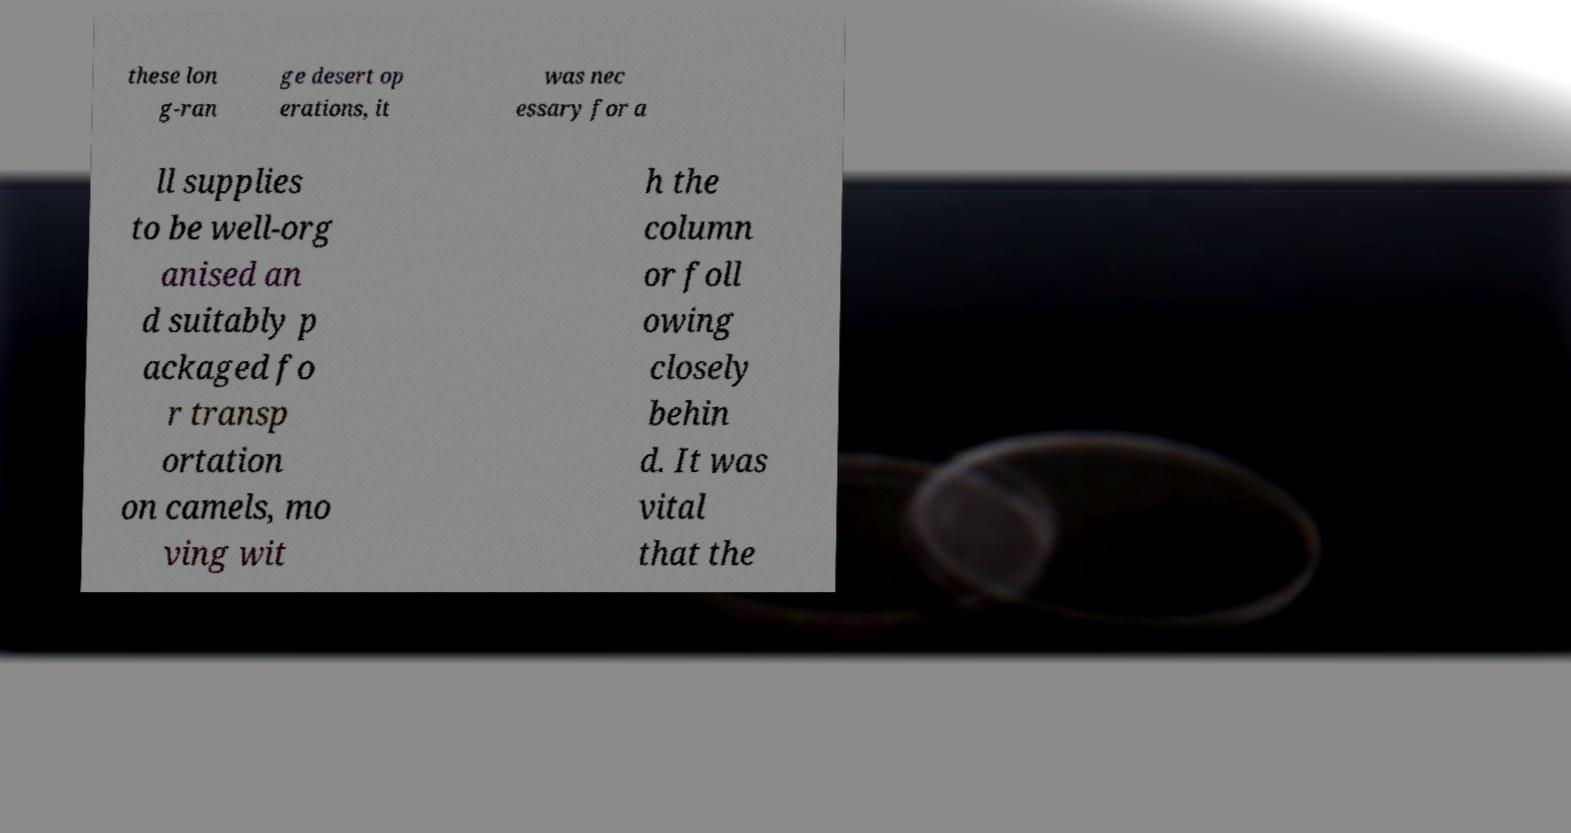Can you read and provide the text displayed in the image?This photo seems to have some interesting text. Can you extract and type it out for me? these lon g-ran ge desert op erations, it was nec essary for a ll supplies to be well-org anised an d suitably p ackaged fo r transp ortation on camels, mo ving wit h the column or foll owing closely behin d. It was vital that the 